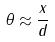<formula> <loc_0><loc_0><loc_500><loc_500>\theta \approx \frac { x } { d }</formula> 